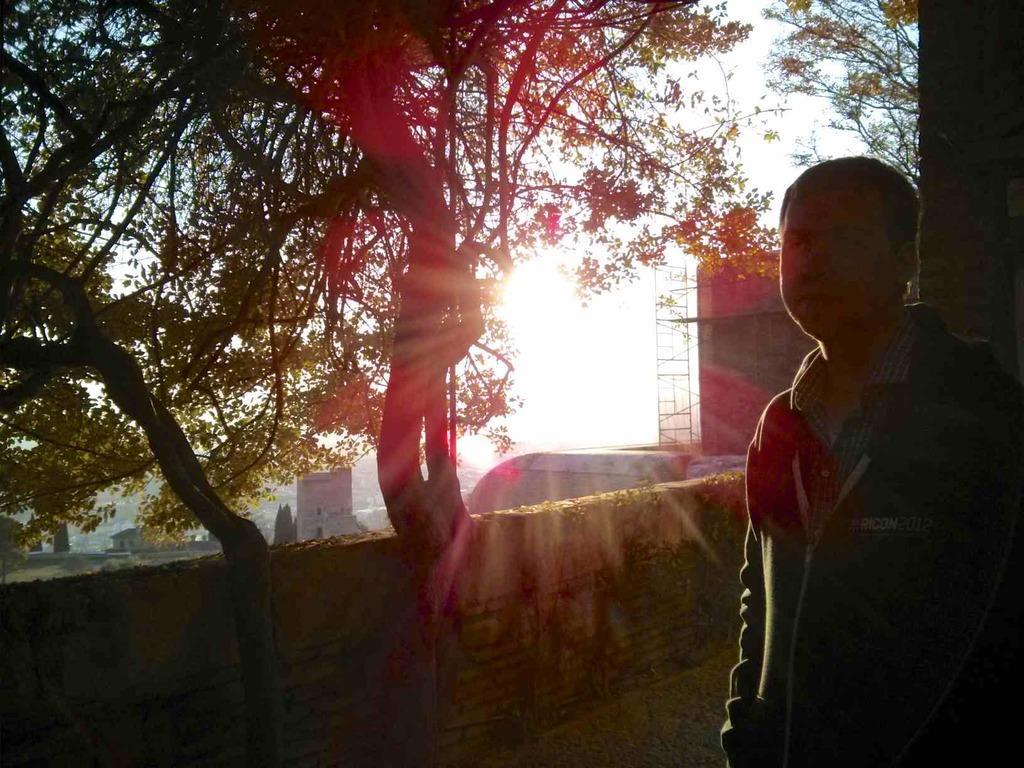Please provide a concise description of this image. In this picture I can see a man standing, there is a wall, there are buildings, trees, and in the background there is sky. 